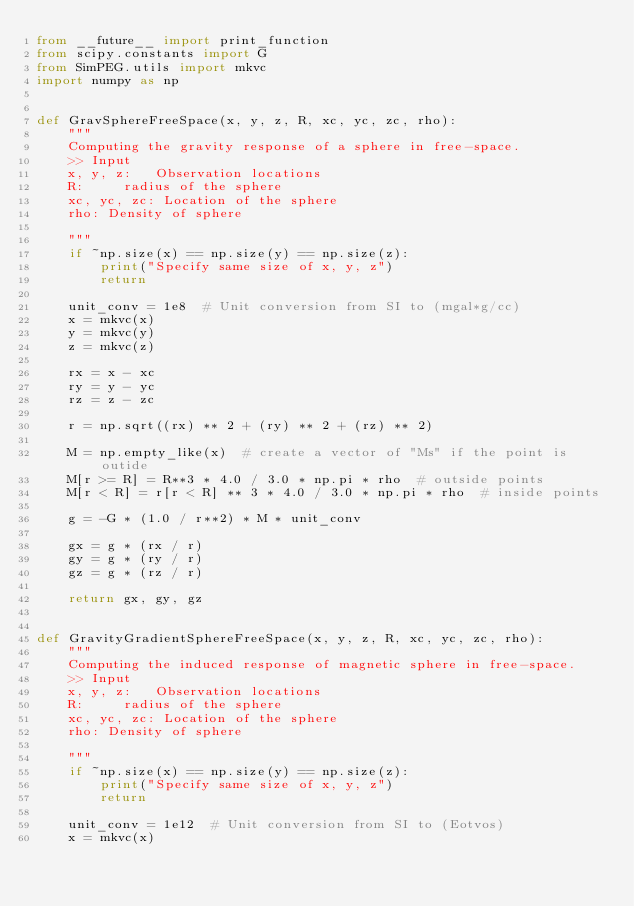Convert code to text. <code><loc_0><loc_0><loc_500><loc_500><_Python_>from __future__ import print_function
from scipy.constants import G
from SimPEG.utils import mkvc
import numpy as np


def GravSphereFreeSpace(x, y, z, R, xc, yc, zc, rho):
    """
    Computing the gravity response of a sphere in free-space.
    >> Input
    x, y, z:   Observation locations
    R:     radius of the sphere
    xc, yc, zc: Location of the sphere
    rho: Density of sphere

    """
    if ~np.size(x) == np.size(y) == np.size(z):
        print("Specify same size of x, y, z")
        return

    unit_conv = 1e8  # Unit conversion from SI to (mgal*g/cc)
    x = mkvc(x)
    y = mkvc(y)
    z = mkvc(z)

    rx = x - xc
    ry = y - yc
    rz = z - zc

    r = np.sqrt((rx) ** 2 + (ry) ** 2 + (rz) ** 2)

    M = np.empty_like(x)  # create a vector of "Ms" if the point is outide
    M[r >= R] = R**3 * 4.0 / 3.0 * np.pi * rho  # outside points
    M[r < R] = r[r < R] ** 3 * 4.0 / 3.0 * np.pi * rho  # inside points

    g = -G * (1.0 / r**2) * M * unit_conv

    gx = g * (rx / r)
    gy = g * (ry / r)
    gz = g * (rz / r)

    return gx, gy, gz


def GravityGradientSphereFreeSpace(x, y, z, R, xc, yc, zc, rho):
    """
    Computing the induced response of magnetic sphere in free-space.
    >> Input
    x, y, z:   Observation locations
    R:     radius of the sphere
    xc, yc, zc: Location of the sphere
    rho: Density of sphere

    """
    if ~np.size(x) == np.size(y) == np.size(z):
        print("Specify same size of x, y, z")
        return

    unit_conv = 1e12  # Unit conversion from SI to (Eotvos)
    x = mkvc(x)</code> 